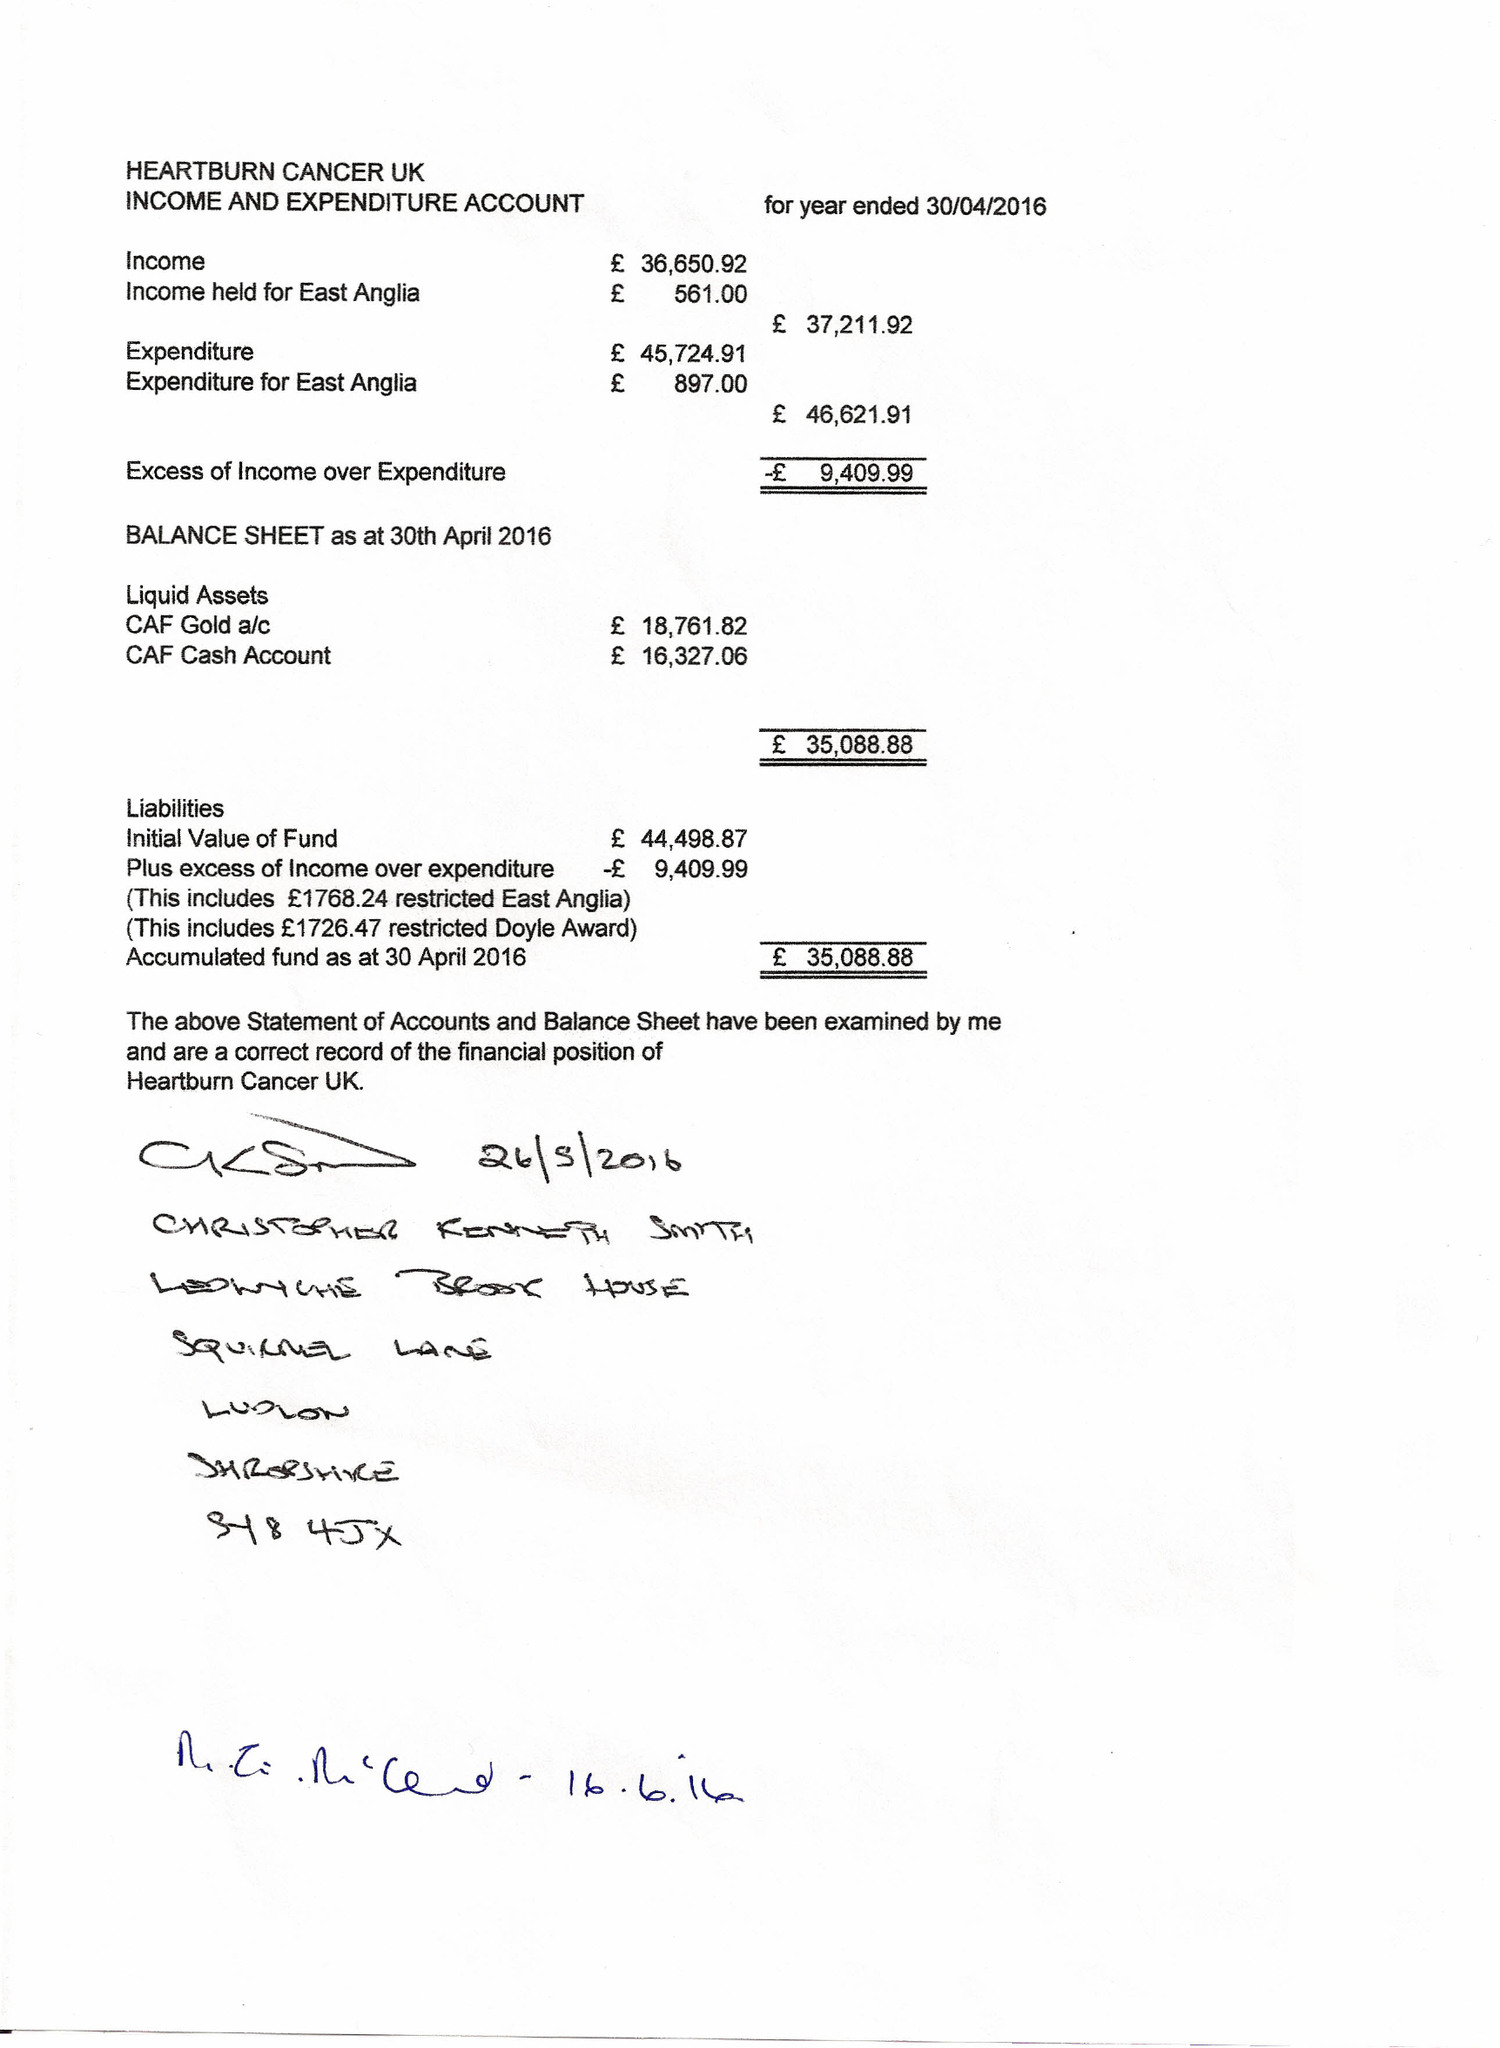What is the value for the address__street_line?
Answer the question using a single word or phrase. WALTON LANE 